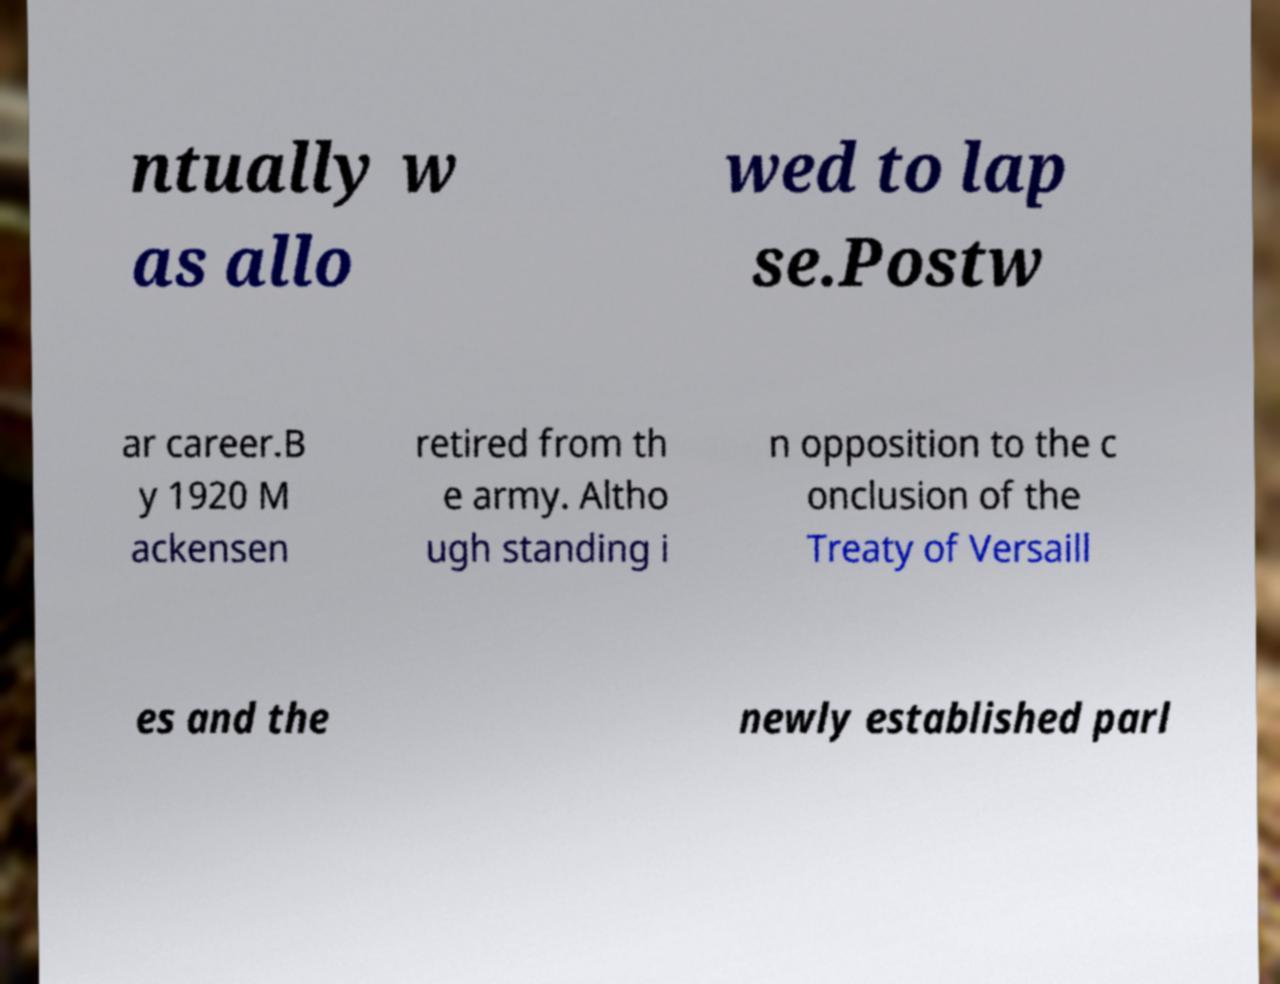What messages or text are displayed in this image? I need them in a readable, typed format. ntually w as allo wed to lap se.Postw ar career.B y 1920 M ackensen retired from th e army. Altho ugh standing i n opposition to the c onclusion of the Treaty of Versaill es and the newly established parl 